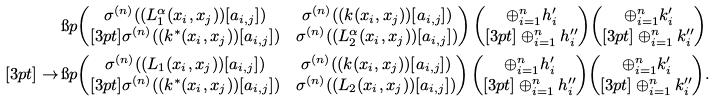Convert formula to latex. <formula><loc_0><loc_0><loc_500><loc_500>& \i p { \begin{pmatrix} \sigma ^ { ( n ) } ( ( L _ { 1 } ^ { \alpha } ( x _ { i } , x _ { j } ) ) [ a _ { i , j } ] ) & \sigma ^ { ( n ) } ( ( k ( x _ { i } , x _ { j } ) ) [ a _ { i , j } ] ) \\ [ 3 p t ] \sigma ^ { ( n ) } ( ( k ^ { \ast } ( x _ { i } , x _ { j } ) ) [ a _ { i , j } ] ) & \sigma ^ { ( n ) } ( ( L _ { 2 } ^ { \alpha } ( x _ { i } , x _ { j } ) ) [ a _ { i , j } ] ) \end{pmatrix} \begin{pmatrix} \oplus _ { i = 1 } ^ { n } h _ { i } ^ { \prime } \\ [ 3 p t ] \oplus _ { i = 1 } ^ { n } h _ { i } ^ { \prime \prime } \end{pmatrix} } { \begin{pmatrix} \oplus _ { i = 1 } ^ { n } k _ { i } ^ { \prime } \\ [ 3 p t ] \oplus _ { i = 1 } ^ { n } k _ { i } ^ { \prime \prime } \end{pmatrix} } \\ [ 3 p t ] \to \, & \i p { \begin{pmatrix} \sigma ^ { ( n ) } ( ( L _ { 1 } ( x _ { i } , x _ { j } ) ) [ a _ { i , j } ] ) & \sigma ^ { ( n ) } ( ( k ( x _ { i } , x _ { j } ) ) [ a _ { i , j } ] ) \\ [ 3 p t ] \sigma ^ { ( n ) } ( ( k ^ { \ast } ( x _ { i } , x _ { j } ) ) [ a _ { i , j } ] ) & \sigma ^ { ( n ) } ( ( L _ { 2 } ( x _ { i } , x _ { j } ) ) [ a _ { i , j } ] ) \end{pmatrix} \begin{pmatrix} \oplus _ { i = 1 } ^ { n } h _ { i } ^ { \prime } \\ [ 3 p t ] \oplus _ { i = 1 } ^ { n } h _ { i } ^ { \prime \prime } \end{pmatrix} } { \begin{pmatrix} \oplus _ { i = 1 } ^ { n } k _ { i } ^ { \prime } \\ [ 3 p t ] \oplus _ { i = 1 } ^ { n } k _ { i } ^ { \prime \prime } \end{pmatrix} } . \\</formula> 